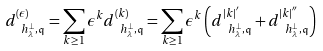Convert formula to latex. <formula><loc_0><loc_0><loc_500><loc_500>d ^ { ( \epsilon ) } _ { \ h _ { \lambda } ^ { \bot } , \mathfrak { q } } = \sum _ { k \geq 1 } \epsilon ^ { k } d ^ { ( k ) } _ { \ h _ { \lambda } ^ { \bot } , \mathfrak { q } } = \sum _ { k \geq 1 } \epsilon ^ { k } \left ( d ^ { | k | ^ { ^ { \prime } } } _ { \ h _ { \lambda } ^ { \bot } , \mathfrak { q } } + d ^ { | k | ^ { ^ { \prime \prime } } } _ { \ h _ { \lambda } ^ { \bot } , \mathfrak { q } } \right )</formula> 